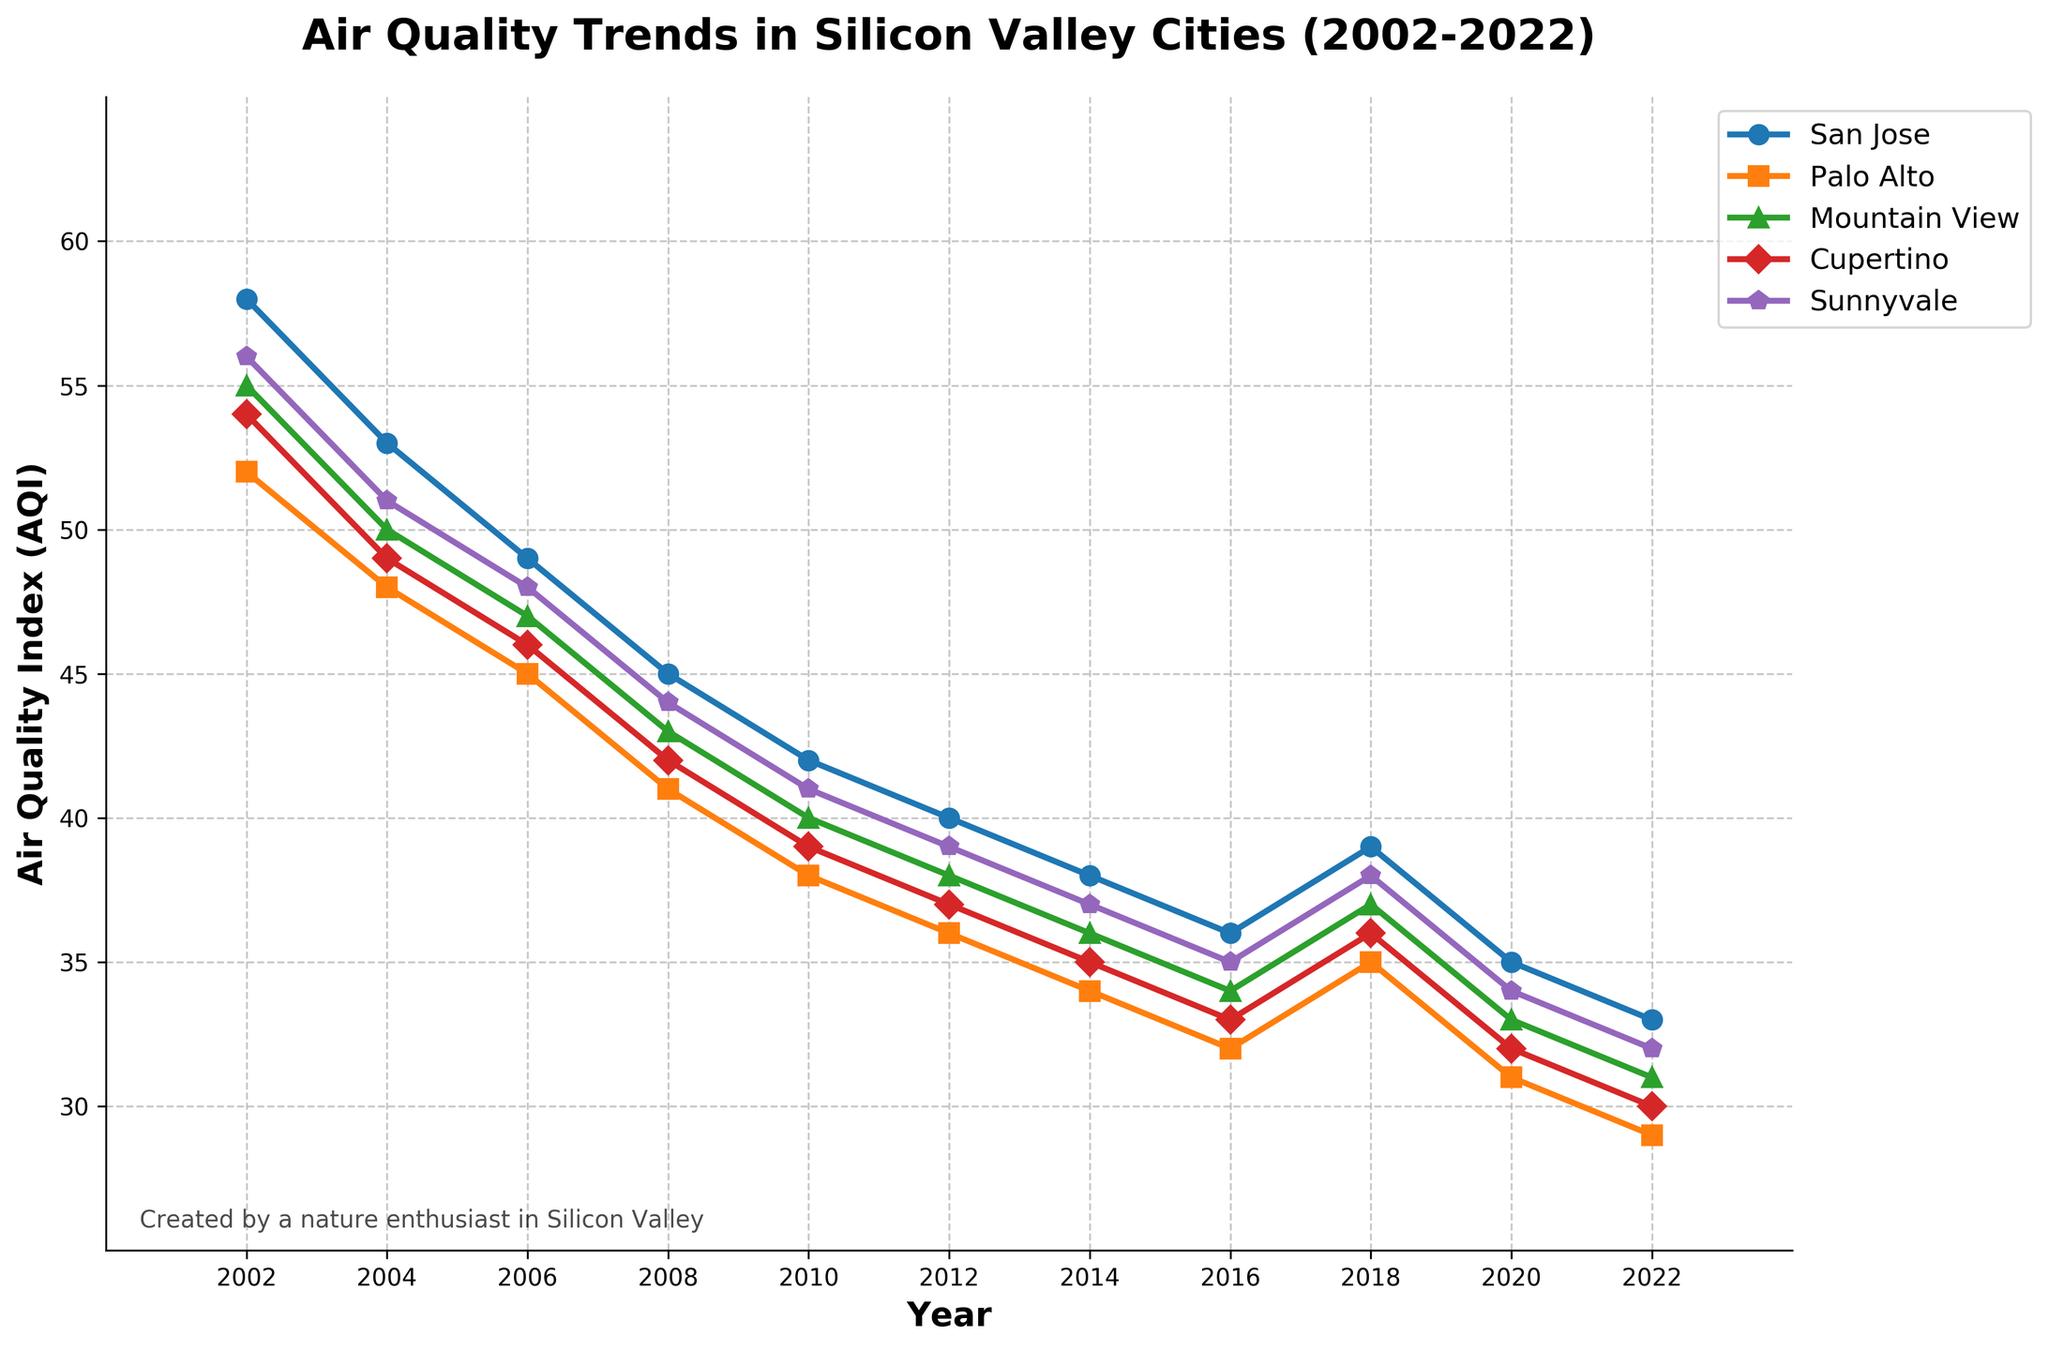What city had the highest AQI in 2022? The city with the highest AQI level in 2022 can be identified by comparing the AQI values of all the cities in that year. Look at the line points for 2022 and check which point is the highest.
Answer: San Jose Which city showed the most improvement in AQI from 2002 to 2022? Improvement in AQI can be determined by calculating the difference between AQI values in 2002 and 2022 for each city. The city with the largest positive difference has shown the most improvement. San Jose improved from 58 to 33, a decrease of 25, others have smaller improvements.
Answer: San Jose Between 2008 and 2012, which city had the smallest decline in AQI? For each city, find the AQI difference between 2008 and 2012. The city with the smallest difference had the smallest decline. For example, San Jose declined from 45 to 40, Palo Alto from 41 to 36, and so forth.
Answer: San Jose Which year had the greatest overall average AQI across all cities? Calculate the average AQI for each year by summing the AQIs of all cities and dividing by the number of cities. The year with the highest average is the answer. For example, in 2002, the average is \( \frac{58+52+55+54+56}{5} \approx 55 \). Repeat for all years.
Answer: 2002 By how much did Sunnyvale's AQI change from 2006 to 2010? Subtract Sunnyvale's AQI in 2010 from its AQI in 2006 to find the change. In 2006, Sunnyvale's AQI was 48, and in 2010, it was 41. Hence, the change is 48 - 41.
Answer: 7 Did any city ever have an AQI lower than 30 in the given period? Look through the AQI levels from 2002 to 2022 for all cities to see if any city's AQI dropped below 30. For example, check each city's AQI values year by year.
Answer: Yes, Palo Alto In which period did Mountain View experience the most significant drop in AQI? Determine the differences in AQI values between consecutive data points for Mountain View. The period with the largest positive difference indicates the most significant drop.
Answer: 2006 to 2008 How does Cupertino's AQI in 2018 compare to its AQI in 2020? Compare Cupertino's AQI levels for the years 2018 and 2020. In 2018, Cupertino's AQI was 36, and in 2020, it was 32.
Answer: It decreased Which city had the most stable AQI trend (smallest overall change) from 2002 to 2022? Calculate the total change in AQI from 2002 to 2022 for each city and compare these values. The city with the smallest total change demonstrates the most stability.
Answer: Cupertino 